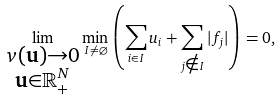Convert formula to latex. <formula><loc_0><loc_0><loc_500><loc_500>\lim _ { \substack { v ( \mathbf u ) \to 0 \\ \mathbf u \in \mathbb { R } ^ { N } _ { + } } } \min _ { I \ne \varnothing } \left ( \sum _ { i \in I } u _ { i } + \sum _ { j \notin I } | f _ { j } | \right ) = 0 ,</formula> 